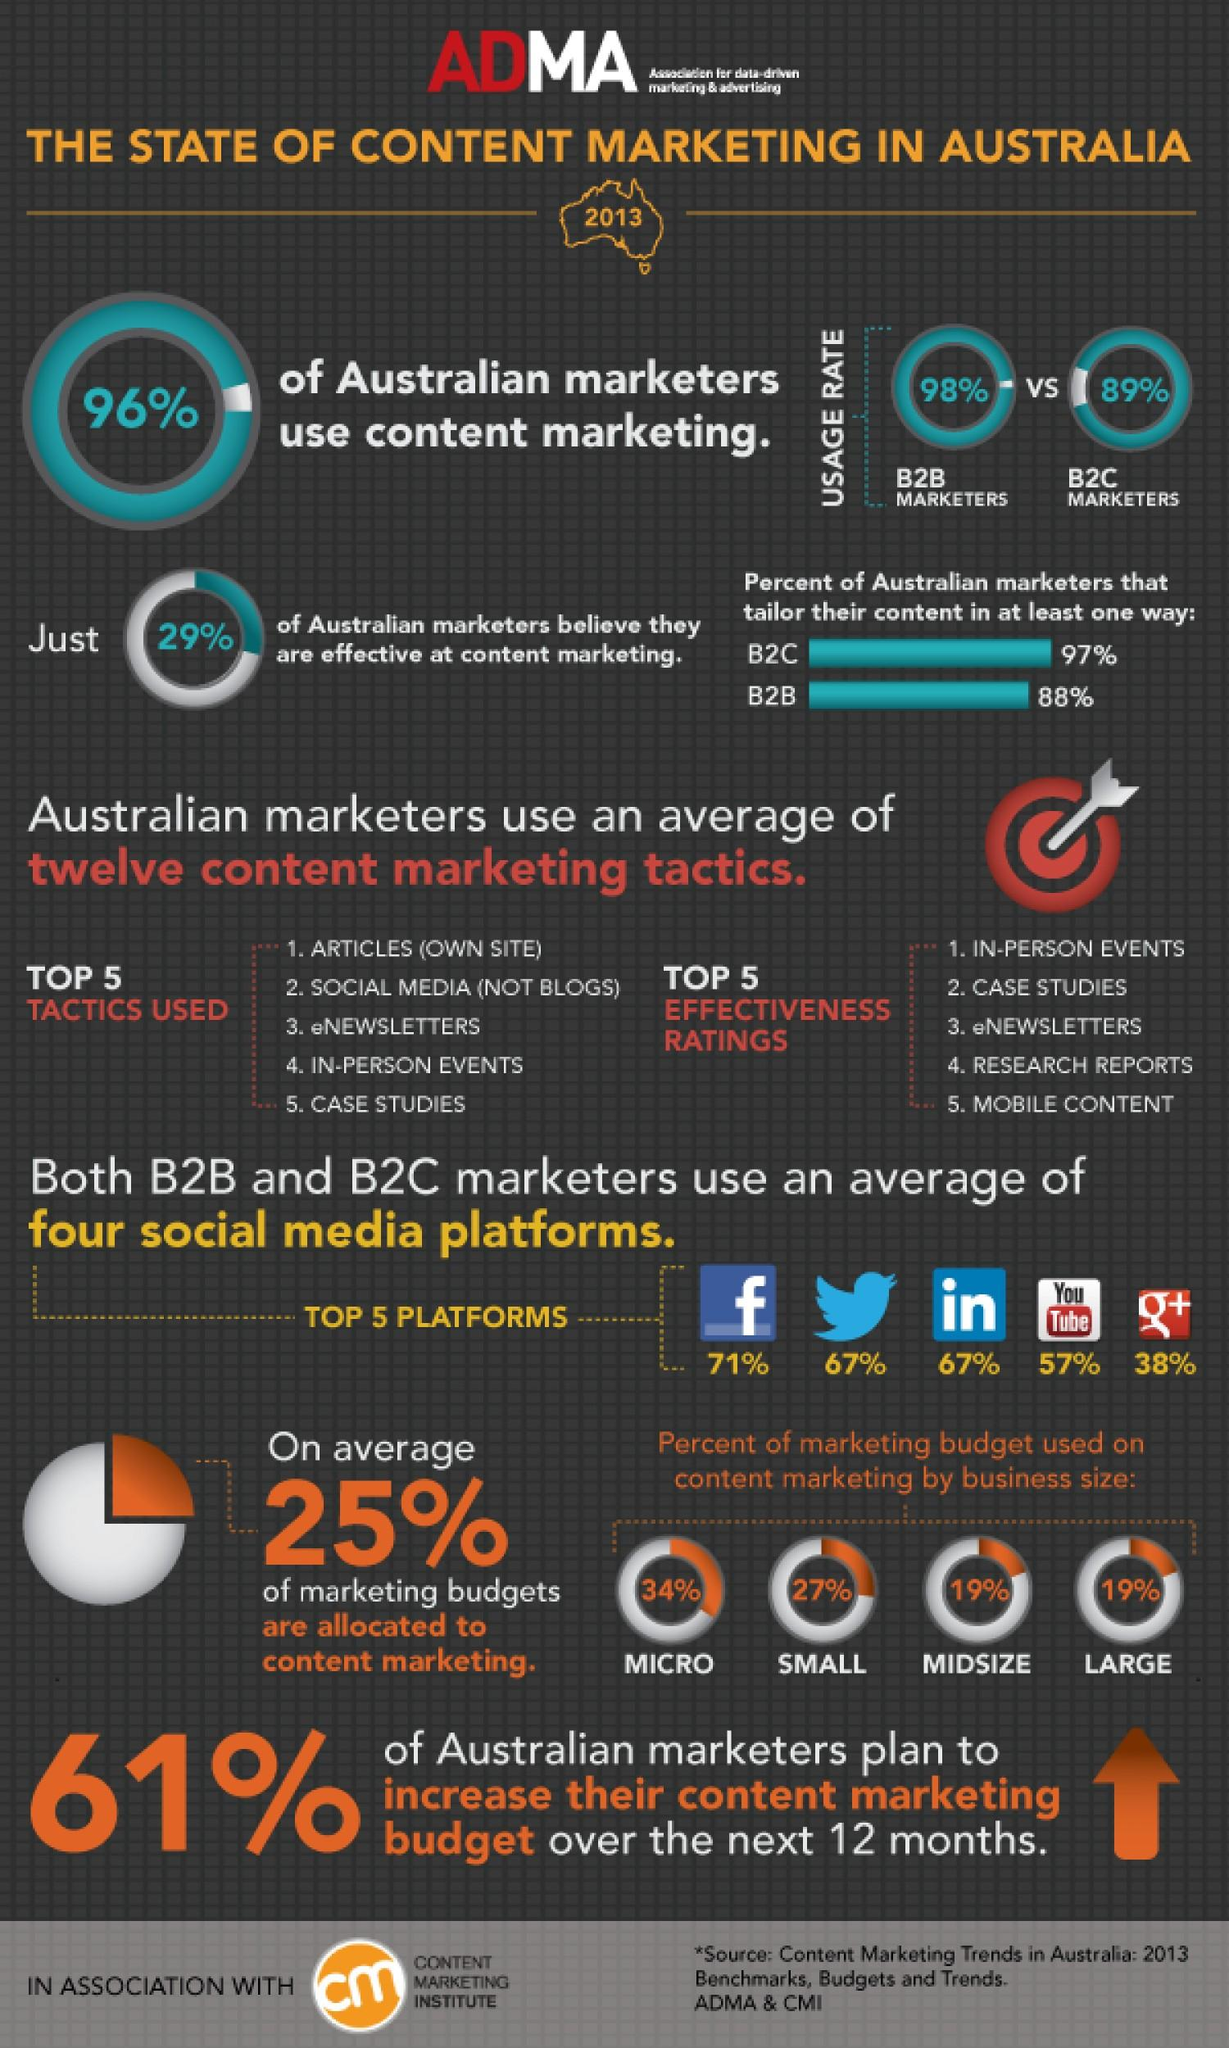Outline some significant characteristics in this image. According to the survey, 57% of marketers use YouTube. Thirty-four percent of micro businesses allocate a significant portion of their marketing budget towards various advertising and promotional activities. Ninety-eight percent of B2B marketers currently utilize content marketing in their marketing strategies. Twenty-five percent of the marketing budget is allocated to content marketing," the speaker declared. Small businesses account for 27% of marketing budgets, with the majority of marketing budgets being allocated to these sized businesses. 